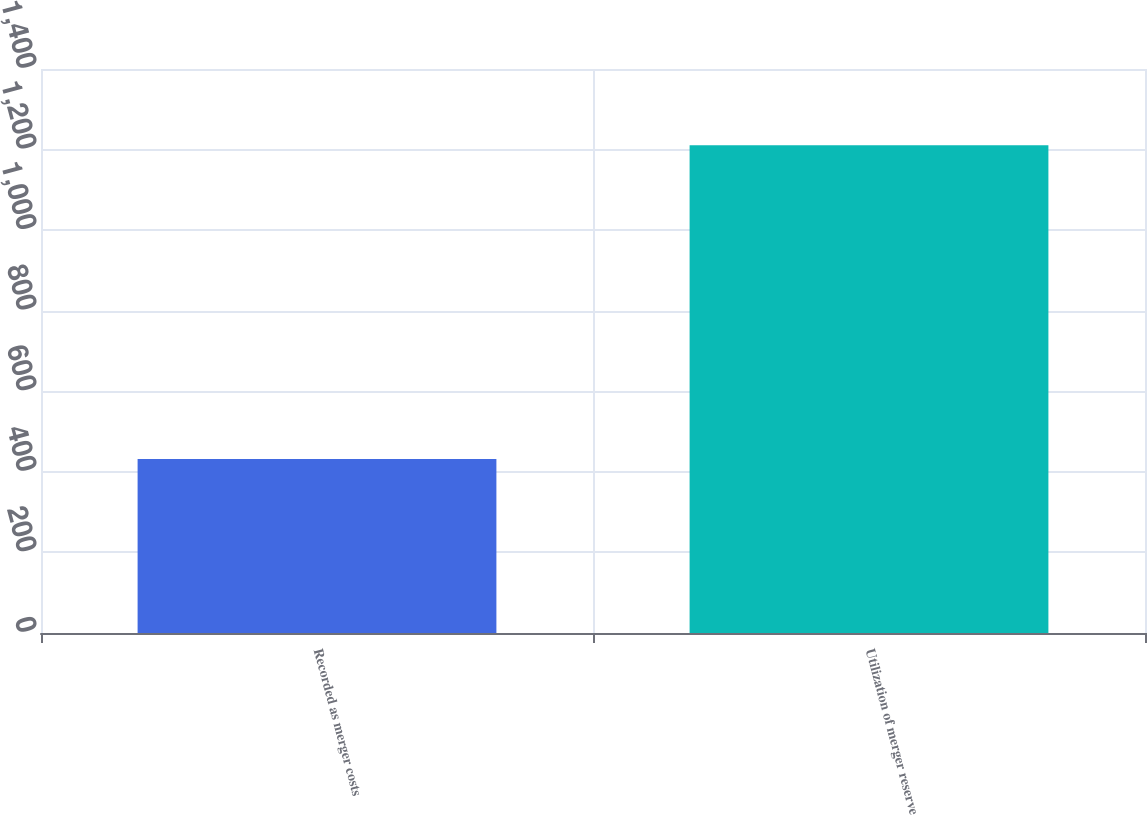<chart> <loc_0><loc_0><loc_500><loc_500><bar_chart><fcel>Recorded as merger costs<fcel>Utilization of merger reserve<nl><fcel>432<fcel>1211<nl></chart> 